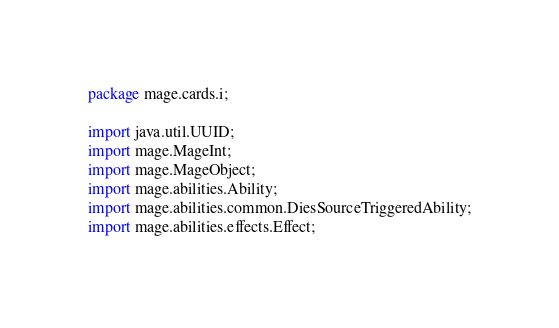<code> <loc_0><loc_0><loc_500><loc_500><_Java_>
package mage.cards.i;

import java.util.UUID;
import mage.MageInt;
import mage.MageObject;
import mage.abilities.Ability;
import mage.abilities.common.DiesSourceTriggeredAbility;
import mage.abilities.effects.Effect;</code> 